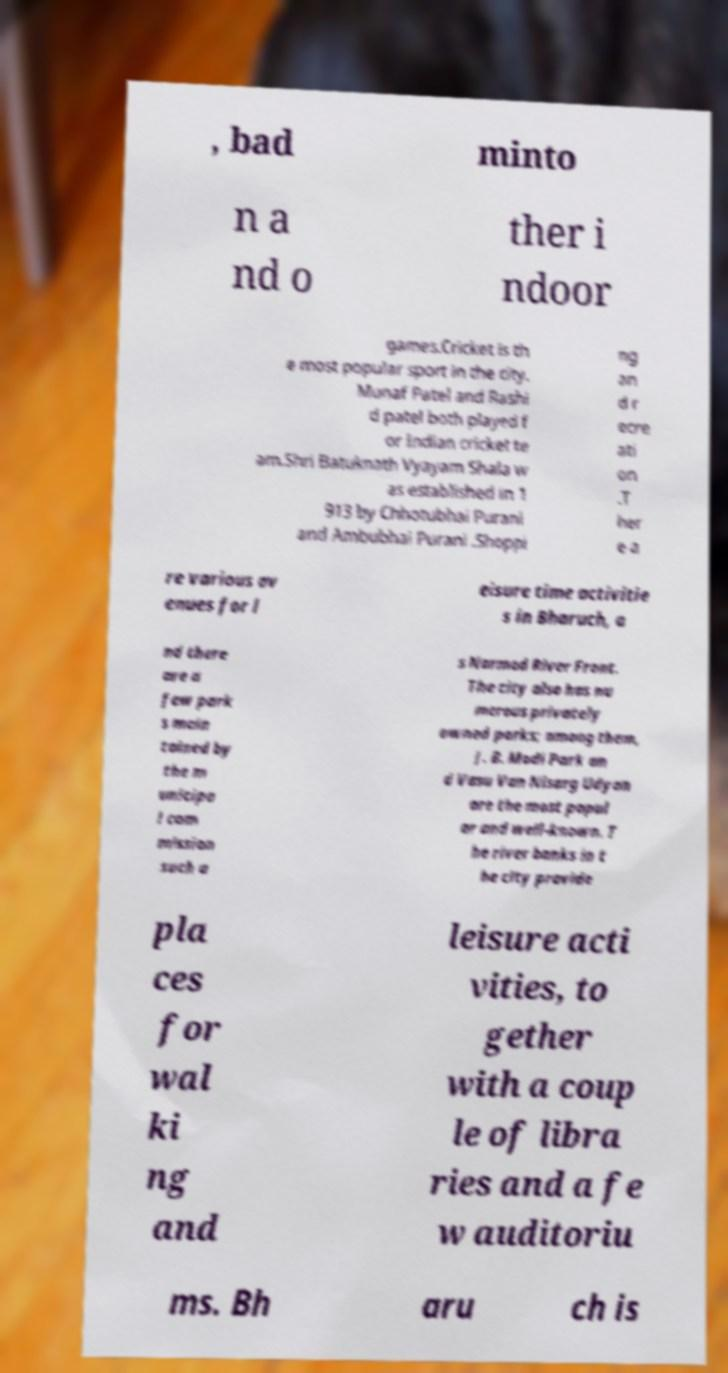Could you assist in decoding the text presented in this image and type it out clearly? , bad minto n a nd o ther i ndoor games.Cricket is th e most popular sport in the city. Munaf Patel and Rashi d patel both played f or Indian cricket te am.Shri Batuknath Vyayam Shala w as established in 1 913 by Chhotubhai Purani and Ambubhai Purani .Shoppi ng an d r ecre ati on .T her e a re various av enues for l eisure time activitie s in Bharuch, a nd there are a few park s main tained by the m unicipa l com mission such a s Narmad River Front. The city also has nu merous privately owned parks; among them, J. B. Modi Park an d Vasu Van Nisarg Udyan are the most popul ar and well-known. T he river banks in t he city provide pla ces for wal ki ng and leisure acti vities, to gether with a coup le of libra ries and a fe w auditoriu ms. Bh aru ch is 